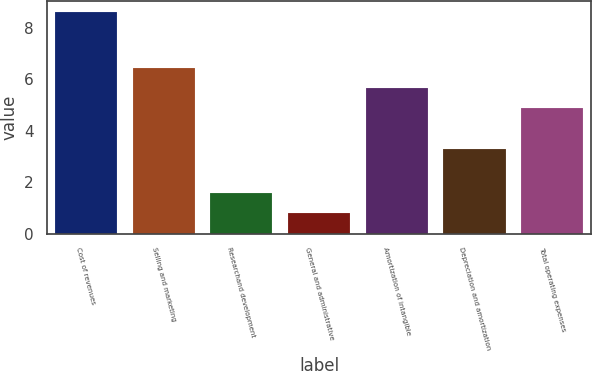Convert chart. <chart><loc_0><loc_0><loc_500><loc_500><bar_chart><fcel>Cost of revenues<fcel>Selling and marketing<fcel>Researchand development<fcel>General and administrative<fcel>Amortization of intangible<fcel>Depreciation and amortization<fcel>Total operating expenses<nl><fcel>8.6<fcel>6.46<fcel>1.58<fcel>0.8<fcel>5.68<fcel>3.3<fcel>4.9<nl></chart> 